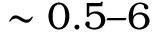<formula> <loc_0><loc_0><loc_500><loc_500>\sim 0 . 5 6</formula> 